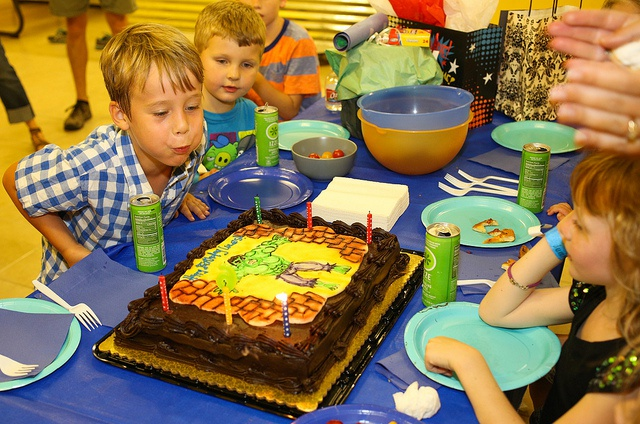Describe the objects in this image and their specific colors. I can see dining table in orange, black, gray, maroon, and aquamarine tones, cake in orange, black, maroon, and yellow tones, people in orange, tan, black, olive, and maroon tones, people in orange, brown, and darkgray tones, and people in orange, tan, red, and salmon tones in this image. 